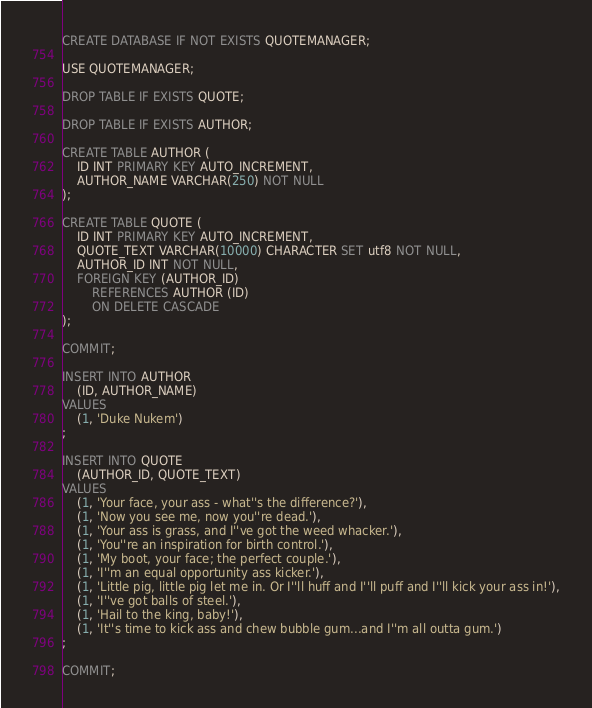<code> <loc_0><loc_0><loc_500><loc_500><_SQL_>CREATE DATABASE IF NOT EXISTS QUOTEMANAGER;

USE QUOTEMANAGER;

DROP TABLE IF EXISTS QUOTE;

DROP TABLE IF EXISTS AUTHOR;

CREATE TABLE AUTHOR (
    ID INT PRIMARY KEY AUTO_INCREMENT,
    AUTHOR_NAME VARCHAR(250) NOT NULL
);

CREATE TABLE QUOTE (
    ID INT PRIMARY KEY AUTO_INCREMENT,
    QUOTE_TEXT VARCHAR(10000) CHARACTER SET utf8 NOT NULL,
    AUTHOR_ID INT NOT NULL,
    FOREIGN KEY (AUTHOR_ID)
        REFERENCES AUTHOR (ID)
        ON DELETE CASCADE
);

COMMIT;

INSERT INTO AUTHOR
    (ID, AUTHOR_NAME)
VALUES
    (1, 'Duke Nukem')
;

INSERT INTO QUOTE
    (AUTHOR_ID, QUOTE_TEXT)
VALUES
    (1, 'Your face, your ass - what''s the difference?'),
    (1, 'Now you see me, now you''re dead.'),
    (1, 'Your ass is grass, and I''ve got the weed whacker.'),
    (1, 'You''re an inspiration for birth control.'),
    (1, 'My boot, your face; the perfect couple.'),
    (1, 'I''m an equal opportunity ass kicker.'),
    (1, 'Little pig, little pig let me in. Or I''ll huff and I''ll puff and I''ll kick your ass in!'),
    (1, 'I''ve got balls of steel.'),
    (1, 'Hail to the king, baby!'),
    (1, 'It''s time to kick ass and chew bubble gum...and I''m all outta gum.')
;

COMMIT;</code> 